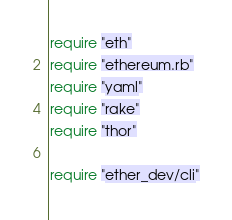Convert code to text. <code><loc_0><loc_0><loc_500><loc_500><_Ruby_>require "eth"
require "ethereum.rb"
require "yaml"
require "rake"
require "thor"

require "ether_dev/cli"
</code> 